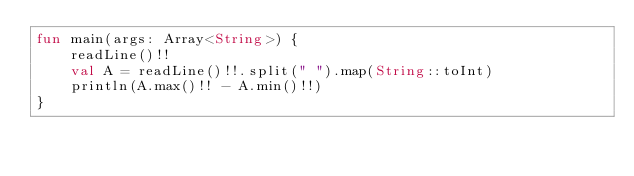Convert code to text. <code><loc_0><loc_0><loc_500><loc_500><_Kotlin_>fun main(args: Array<String>) {
    readLine()!!
    val A = readLine()!!.split(" ").map(String::toInt)
    println(A.max()!! - A.min()!!)
}

</code> 